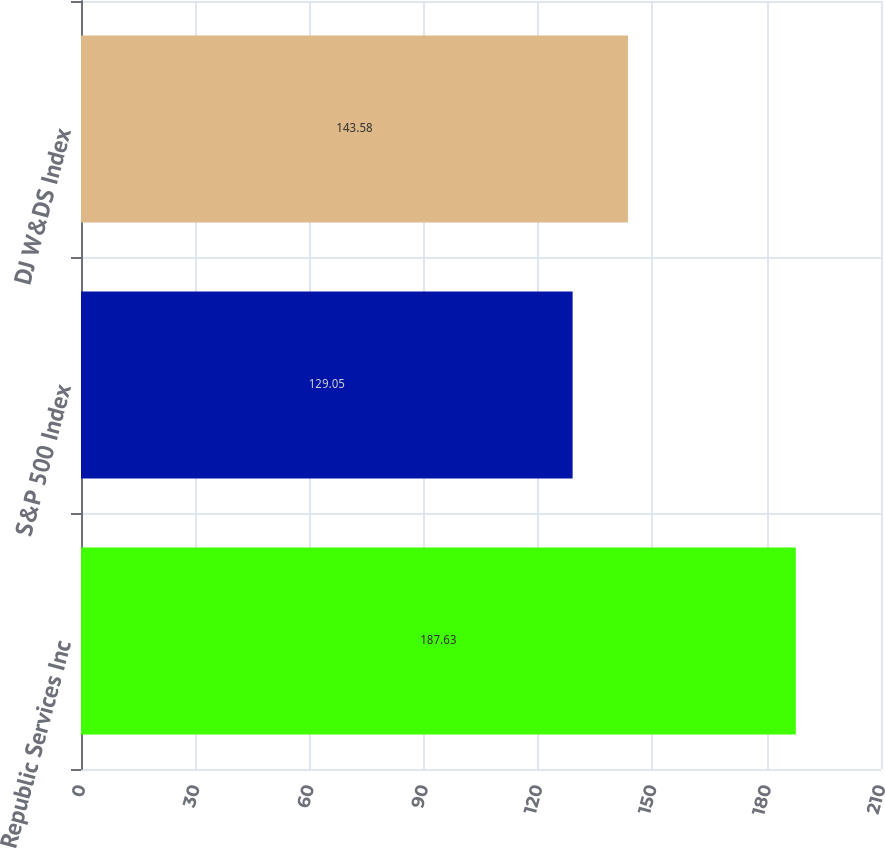<chart> <loc_0><loc_0><loc_500><loc_500><bar_chart><fcel>Republic Services Inc<fcel>S&P 500 Index<fcel>DJ W&DS Index<nl><fcel>187.63<fcel>129.05<fcel>143.58<nl></chart> 